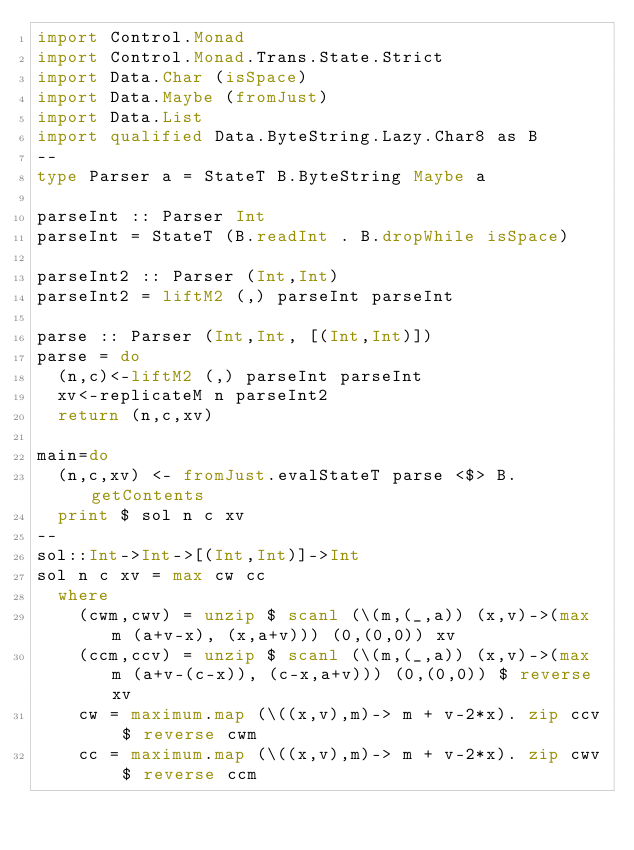Convert code to text. <code><loc_0><loc_0><loc_500><loc_500><_Haskell_>import Control.Monad
import Control.Monad.Trans.State.Strict
import Data.Char (isSpace)
import Data.Maybe (fromJust)
import Data.List
import qualified Data.ByteString.Lazy.Char8 as B
--
type Parser a = StateT B.ByteString Maybe a

parseInt :: Parser Int
parseInt = StateT (B.readInt . B.dropWhile isSpace)

parseInt2 :: Parser (Int,Int)
parseInt2 = liftM2 (,) parseInt parseInt

parse :: Parser (Int,Int, [(Int,Int)])
parse = do
  (n,c)<-liftM2 (,) parseInt parseInt
  xv<-replicateM n parseInt2
  return (n,c,xv)

main=do
  (n,c,xv) <- fromJust.evalStateT parse <$> B.getContents
  print $ sol n c xv
--
sol::Int->Int->[(Int,Int)]->Int
sol n c xv = max cw cc
  where
    (cwm,cwv) = unzip $ scanl (\(m,(_,a)) (x,v)->(max m (a+v-x), (x,a+v))) (0,(0,0)) xv
    (ccm,ccv) = unzip $ scanl (\(m,(_,a)) (x,v)->(max m (a+v-(c-x)), (c-x,a+v))) (0,(0,0)) $ reverse xv
    cw = maximum.map (\((x,v),m)-> m + v-2*x). zip ccv $ reverse cwm
    cc = maximum.map (\((x,v),m)-> m + v-2*x). zip cwv $ reverse ccm

</code> 